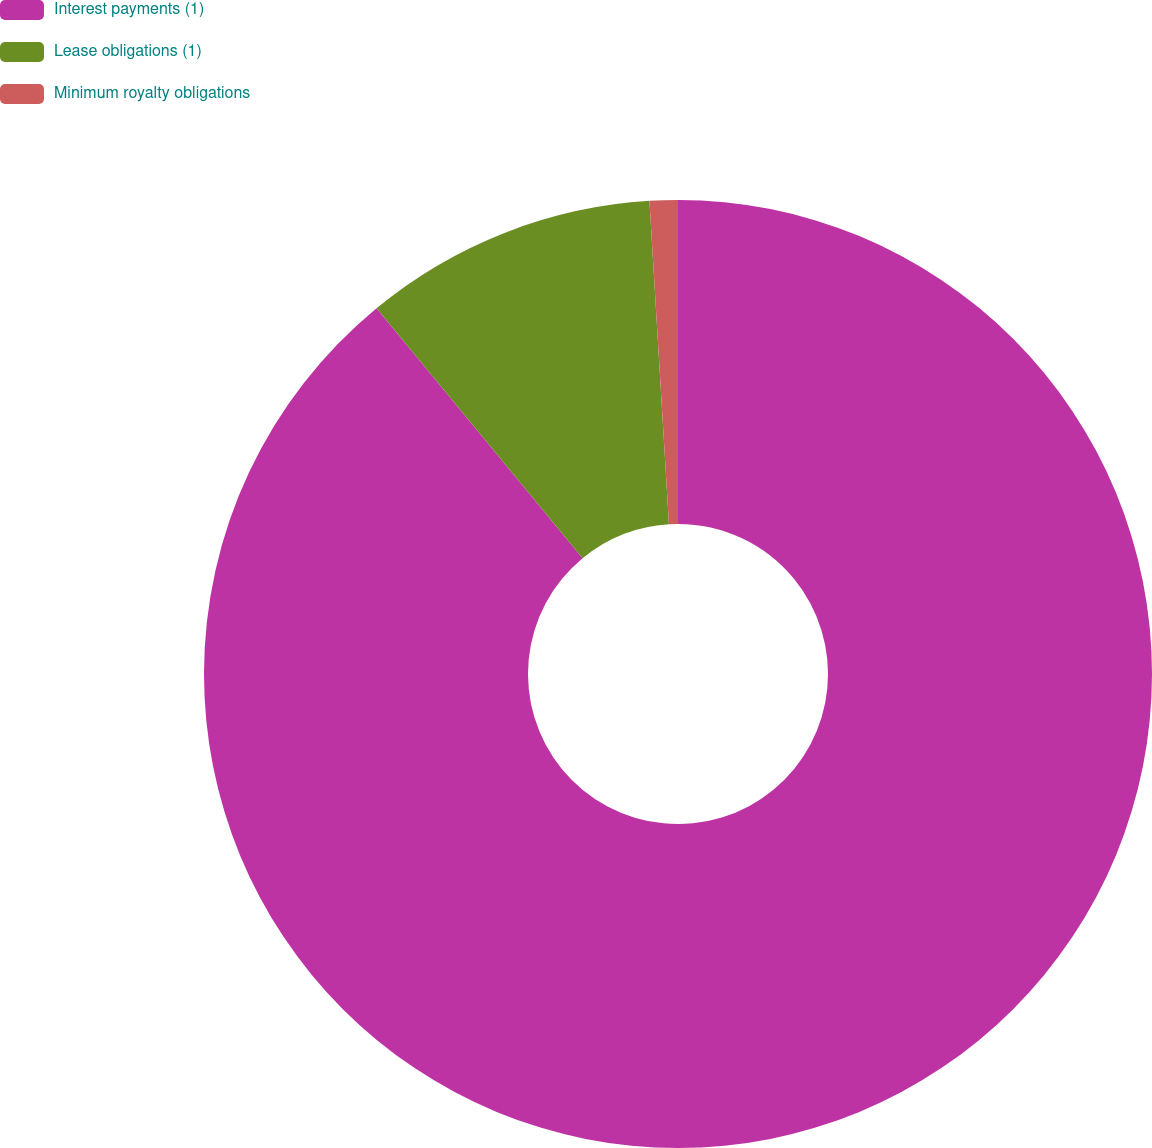<chart> <loc_0><loc_0><loc_500><loc_500><pie_chart><fcel>Interest payments (1)<fcel>Lease obligations (1)<fcel>Minimum royalty obligations<nl><fcel>89.03%<fcel>10.01%<fcel>0.96%<nl></chart> 